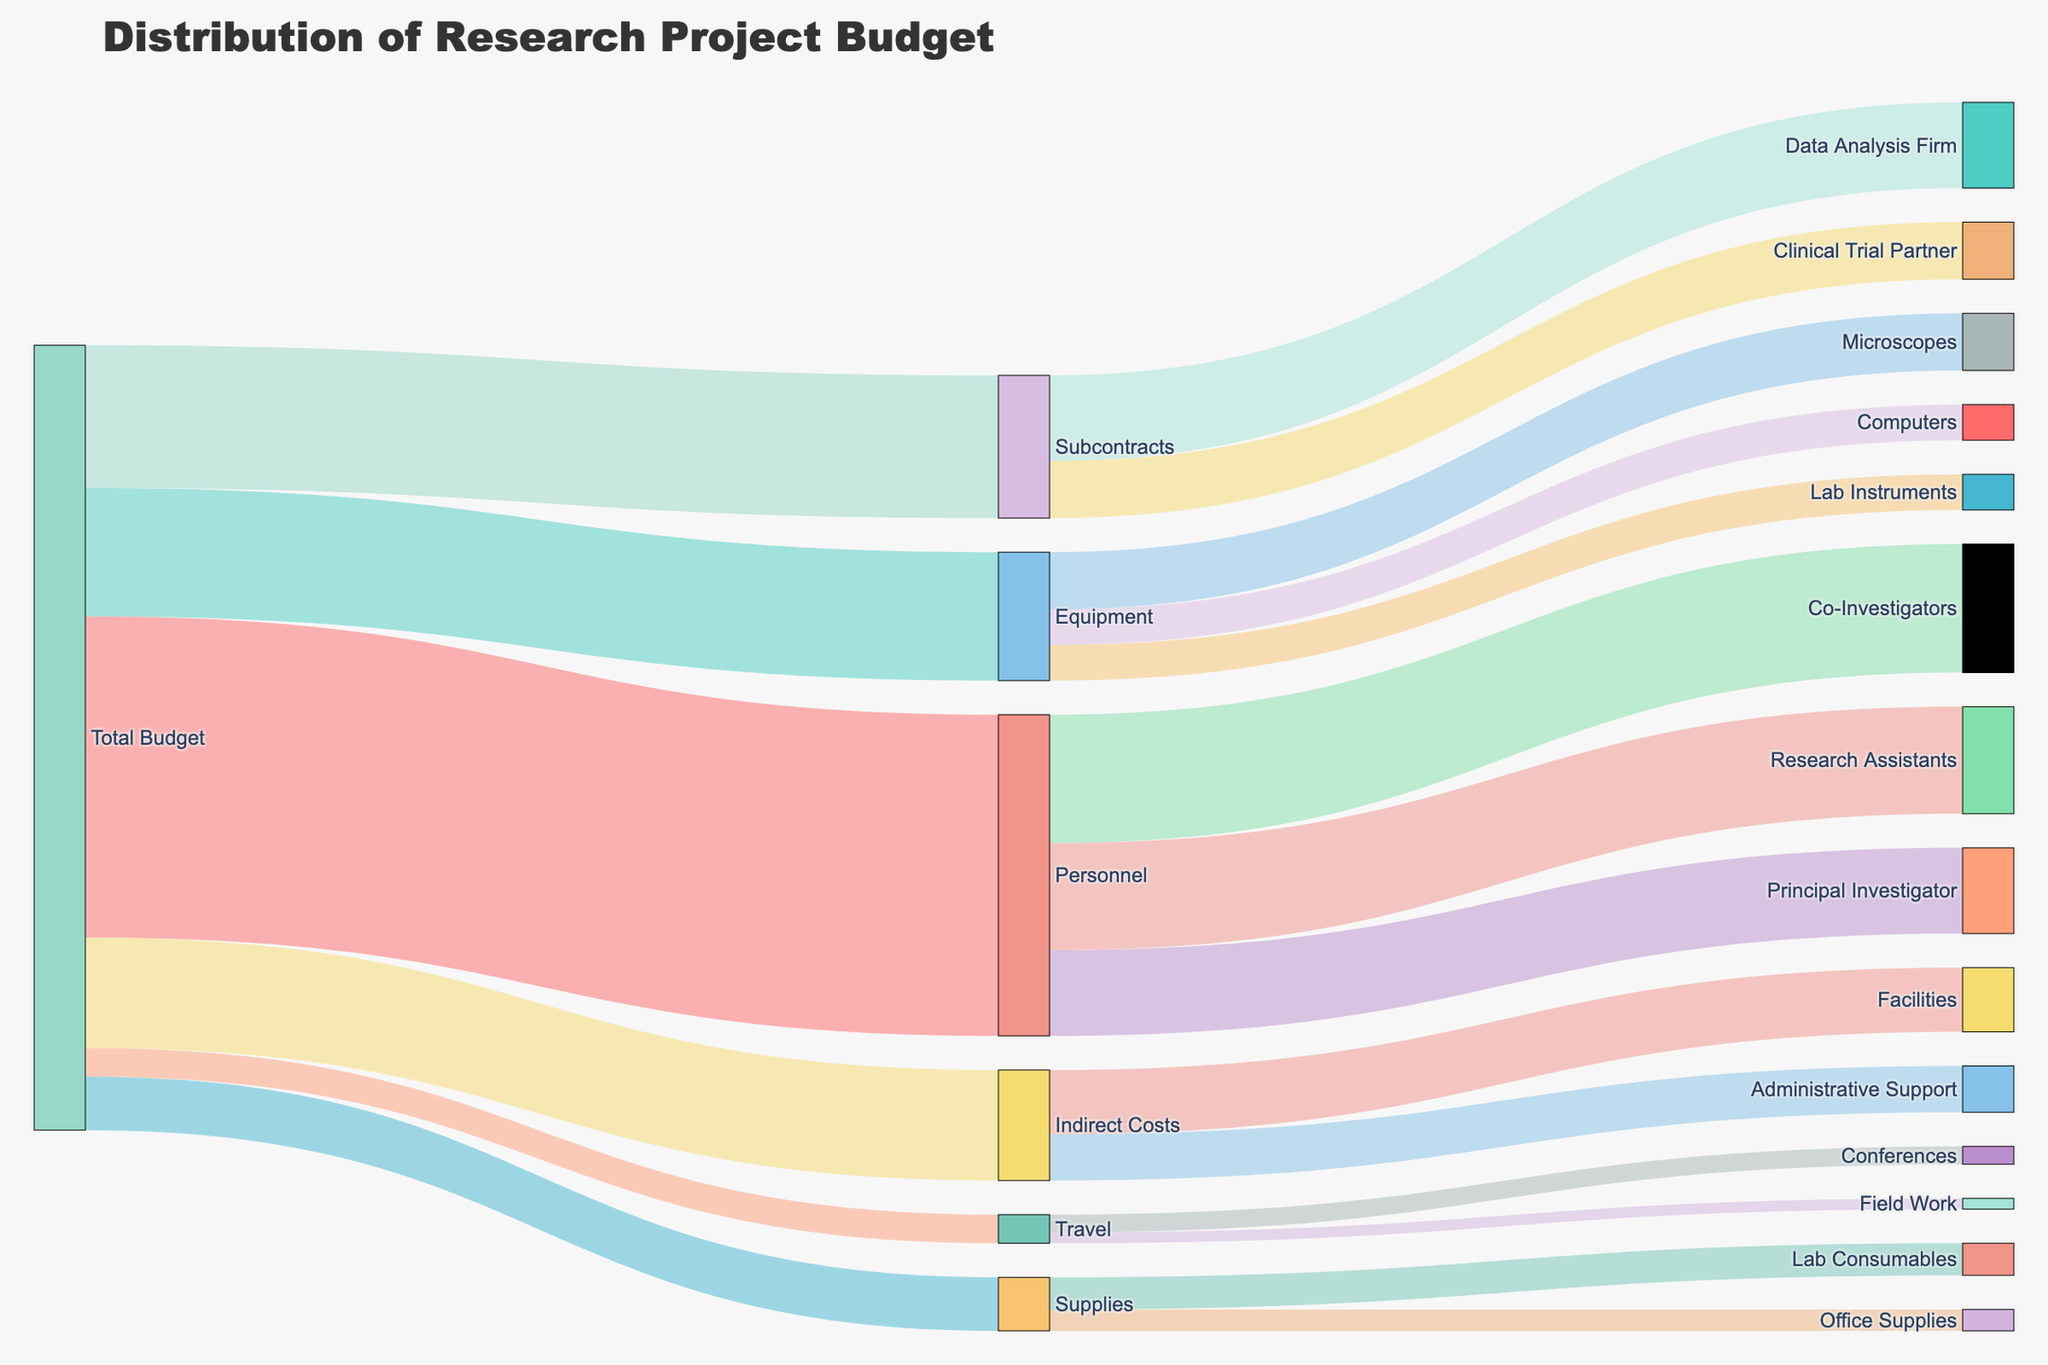What is the title of the figure? The title is displayed at the top of the figure and should be prominently visible.
Answer: Distribution of Research Project Budget How much budget is allocated to 'Travel'? Look for the link labeled 'Travel' originating from 'Total Budget' and note the value associated with it.
Answer: 40,000 Which category receives the most funding from 'Personnel'? Identify the subcategories under 'Personnel' and compare their values.
Answer: Co-Investigators What is the total budget allocated to 'Equipment' and 'Supplies' combined? Sum the values of 'Equipment' and 'Supplies' which are both linked from 'Total Budget'. (180,000 + 75,000)
Answer: 255,000 Compare the budgets allocated to 'Data Analysis Firm' and 'Clinical Trial Partner'. Which one is greater? Locate both subcategories under 'Subcontracts' and compare their values.
Answer: Data Analysis Firm How much of the budget is dedicated to 'Indirect Costs'? Find the link named 'Indirect Costs' from 'Total Budget' and note the value.
Answer: 155,000 What is the total funding allocated to 'Microscopes', 'Computers', and 'Lab Instruments'? Sum the values of 'Microscopes', 'Computers', and 'Lab Instruments' under 'Equipment'. (80,000 + 50,000 + 50,000)
Answer: 180,000 How much budget is allocated to 'Administrative Support' under 'Indirect Costs'? Find the 'Administrative Support' link under 'Indirect Costs' and note the value.
Answer: 65,000 Is the budget for 'Lab Consumables' higher or lower than that for 'Field Work'? Compare the values for 'Lab Consumables' under 'Supplies' and 'Field Work' under 'Travel'.
Answer: Higher What is the total budget allocated to all types of 'Personnel'? Sum the values of the subcategories under 'Personnel'. (120,000 + 180,000 + 150,000)
Answer: 450,000 